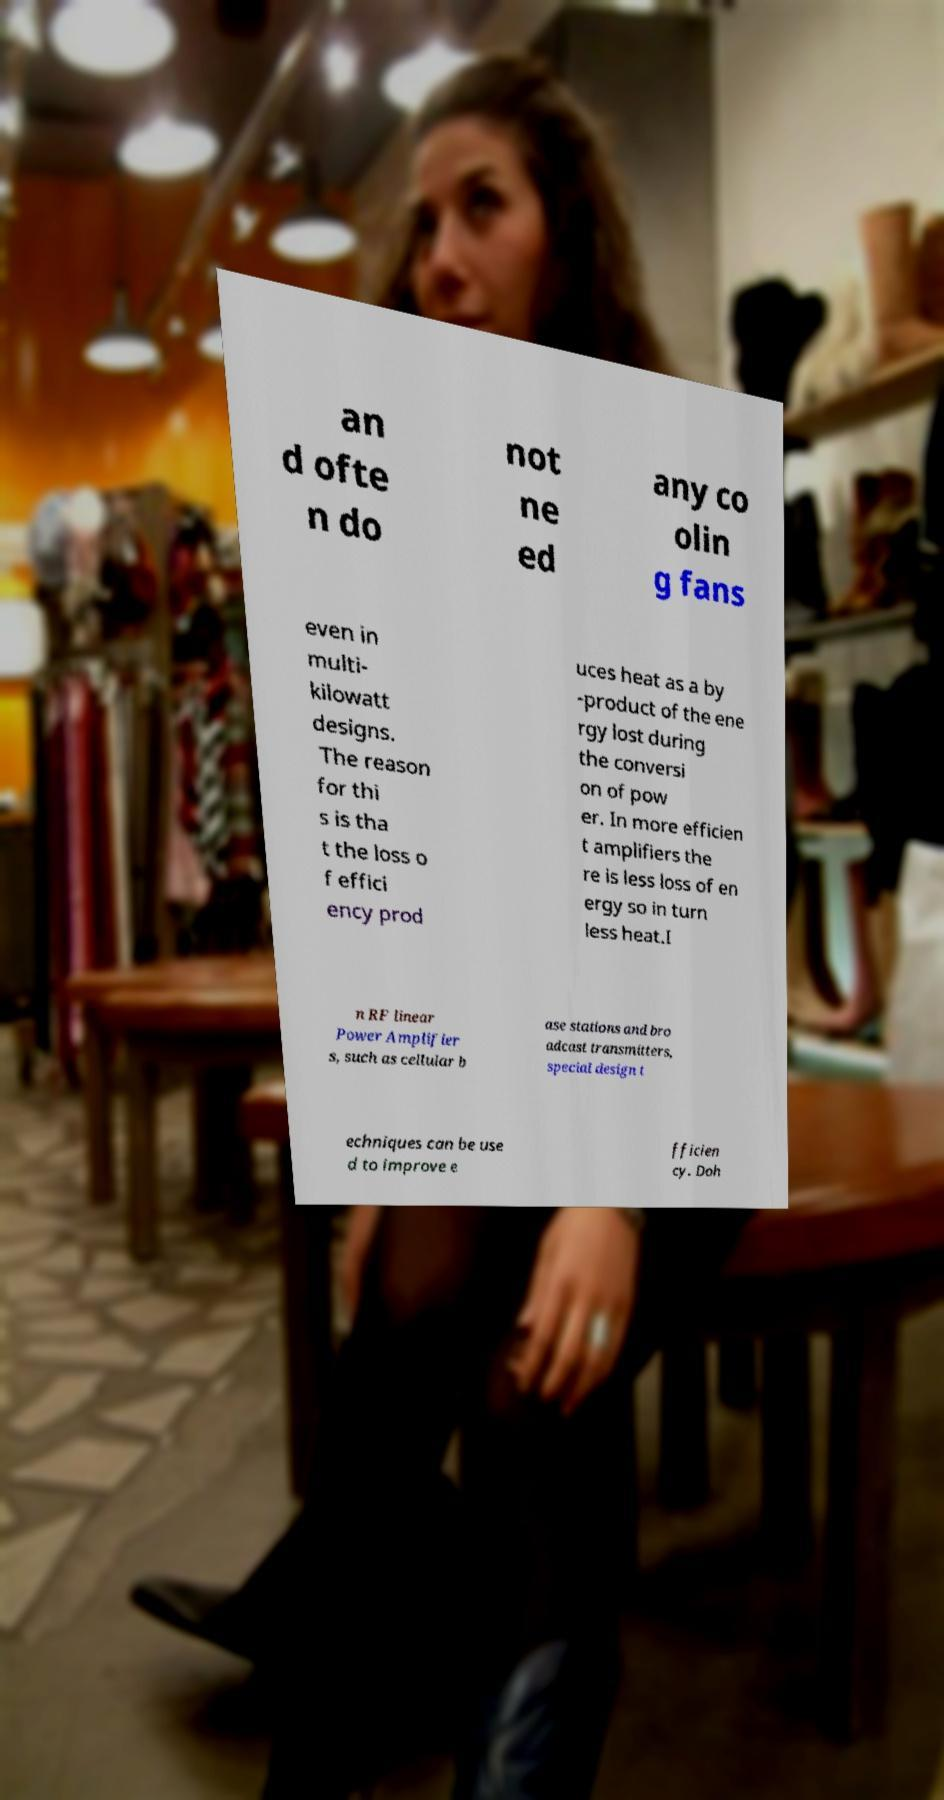I need the written content from this picture converted into text. Can you do that? an d ofte n do not ne ed any co olin g fans even in multi- kilowatt designs. The reason for thi s is tha t the loss o f effici ency prod uces heat as a by -product of the ene rgy lost during the conversi on of pow er. In more efficien t amplifiers the re is less loss of en ergy so in turn less heat.I n RF linear Power Amplifier s, such as cellular b ase stations and bro adcast transmitters, special design t echniques can be use d to improve e fficien cy. Doh 